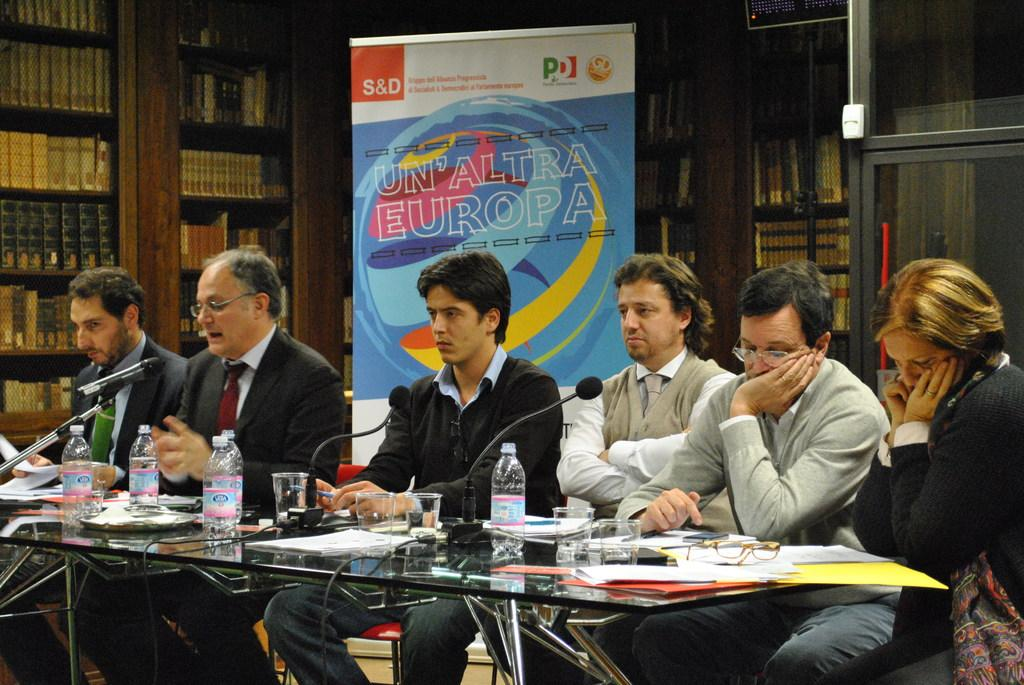<image>
Write a terse but informative summary of the picture. the word europa on a sign behind the people 